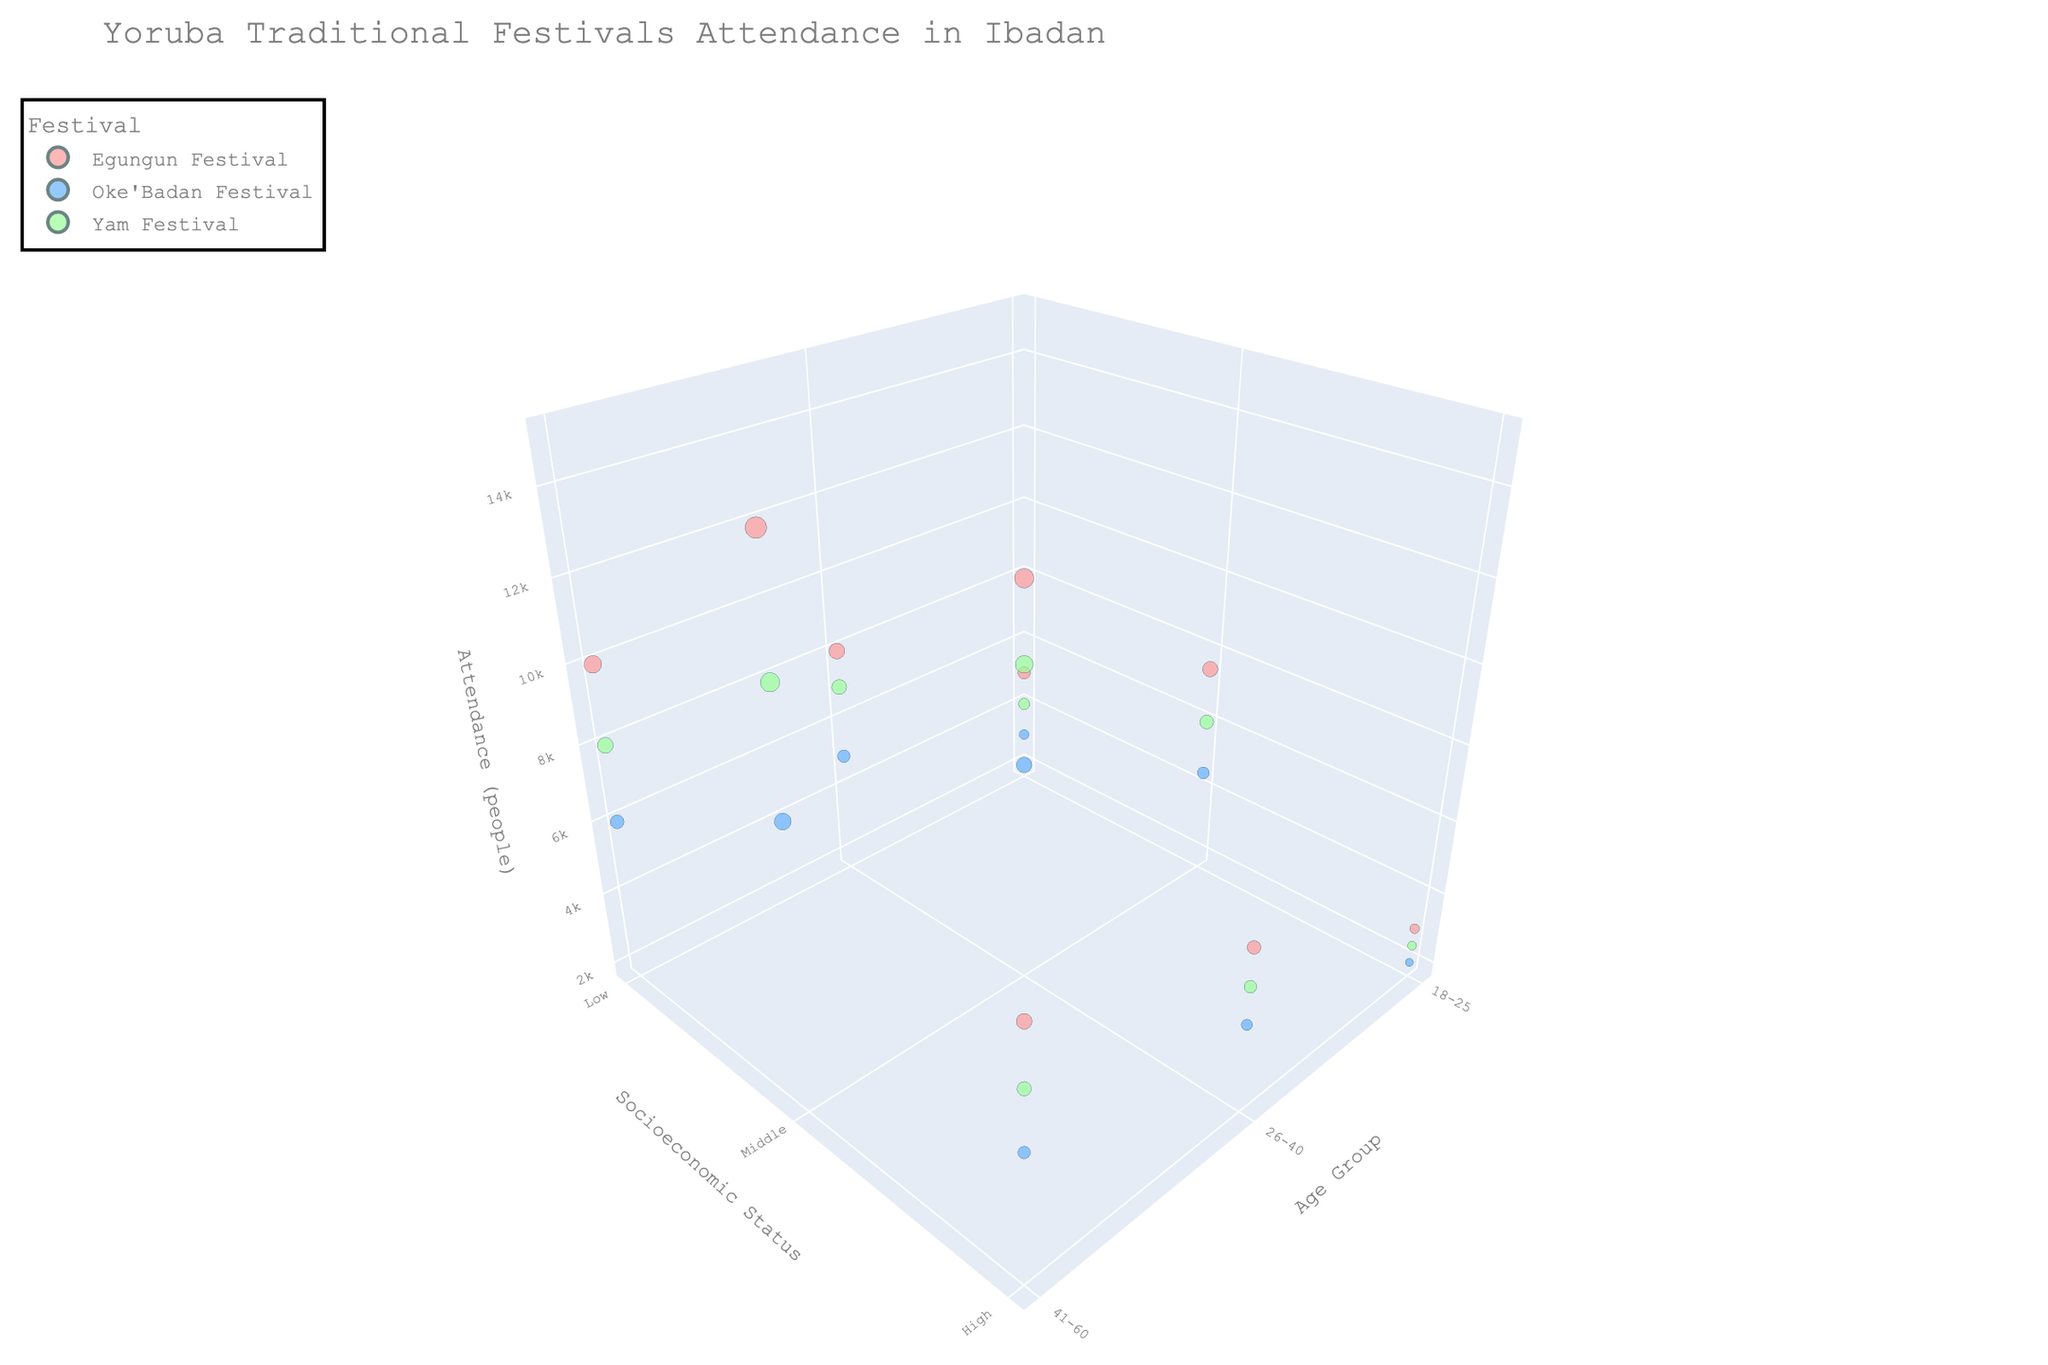what is the title of the figure? The title of a figure is typically displayed at the top of the chart. It provides a summary of the figure's content. Here, the title is given in the code snippet.
Answer: "Yoruba Traditional Festivals Attendance in Ibadan" What are the three socioeconomic statuses displayed in the figure? Socioeconomic status is categorized into different levels and displayed on one of the axes (y-axis) in the figure. The provided data includes these specific categories.
Answer: Low, Middle, High Which age group has the highest attendance for the Egungun Festival? To find this, look at the size of the bubbles for 'Egungun Festival' across different age groups. The larger the bubble, the higher the attendance.
Answer: 41-60 Compare the attendance of the Oke'Badan Festival across socioeconomic statuses for the age group 26-40. Which status has the highest attendance? Check the bubble sizes for 'Oke'Badan Festival' within the 26-40 age group across Low, Middle, and High socioeconomic statuses. The largest bubble represents the highest attendance.
Answer: Middle What color represents the Yam Festival in the chart? The color map in the code snippet shows that each festival type is assigned a different color. Look for the color related to 'Yam Festival'.
Answer: Light green What is the total attendance for the Egungun Festival across all age groups and socioeconomic statuses? Sum the attendance for the Egungun Festival for all age groups and statuses: 5000 + 7500 + 3000 + 8000 + 12000 + 6000 + 10000 + 15000 + 8000 = 75500.
Answer: 75500 Is there a noticeable pattern in festival attendance concerning age groups and socioeconomic status? To determine patterns, examine the placement and sizes of bubbles for different festivals based on age groups and socioeconomic statuses. A detailed analysis suggests higher attendance in middle socioeconomic statuses and increased attendance with aging.
Answer: Yes, older age groups and middle socioeconomic statuses tend to have higher attendance What does the bubble size represent in the 3D chart? Bubble size is a visual representation of the absolute number of attendees for a particular festival, age group, and socioeconomic status.
Answer: attendance Which festival attracts the highest attendance in the 18-25 age group for the middle socioeconomic status? Check the 3D plot for the middle economic status in the 18-25 age group and see the largest bubble.
Answer: Egungun Festival Compare attendance for the Yam Festival between high socioeconomic status and middle socioeconomic status in the age group 41-60. Which has more attendees? Look at the bubble sizes in the 41-60 age group for high and middle socioeconomic statuses for the Yam Festival. The largest bubble indicates more attendees.
Answer: Middle 